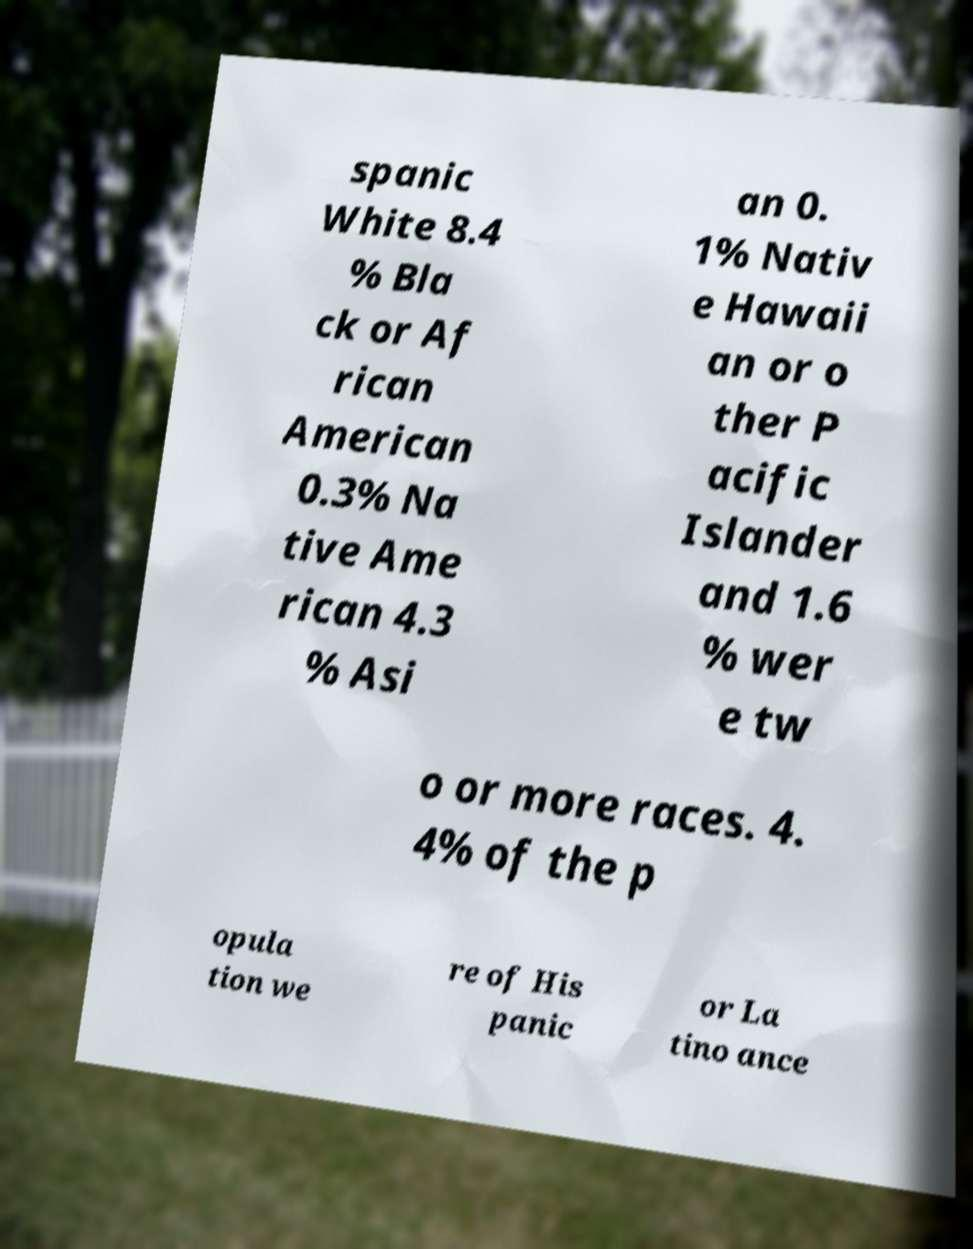Please read and relay the text visible in this image. What does it say? spanic White 8.4 % Bla ck or Af rican American 0.3% Na tive Ame rican 4.3 % Asi an 0. 1% Nativ e Hawaii an or o ther P acific Islander and 1.6 % wer e tw o or more races. 4. 4% of the p opula tion we re of His panic or La tino ance 